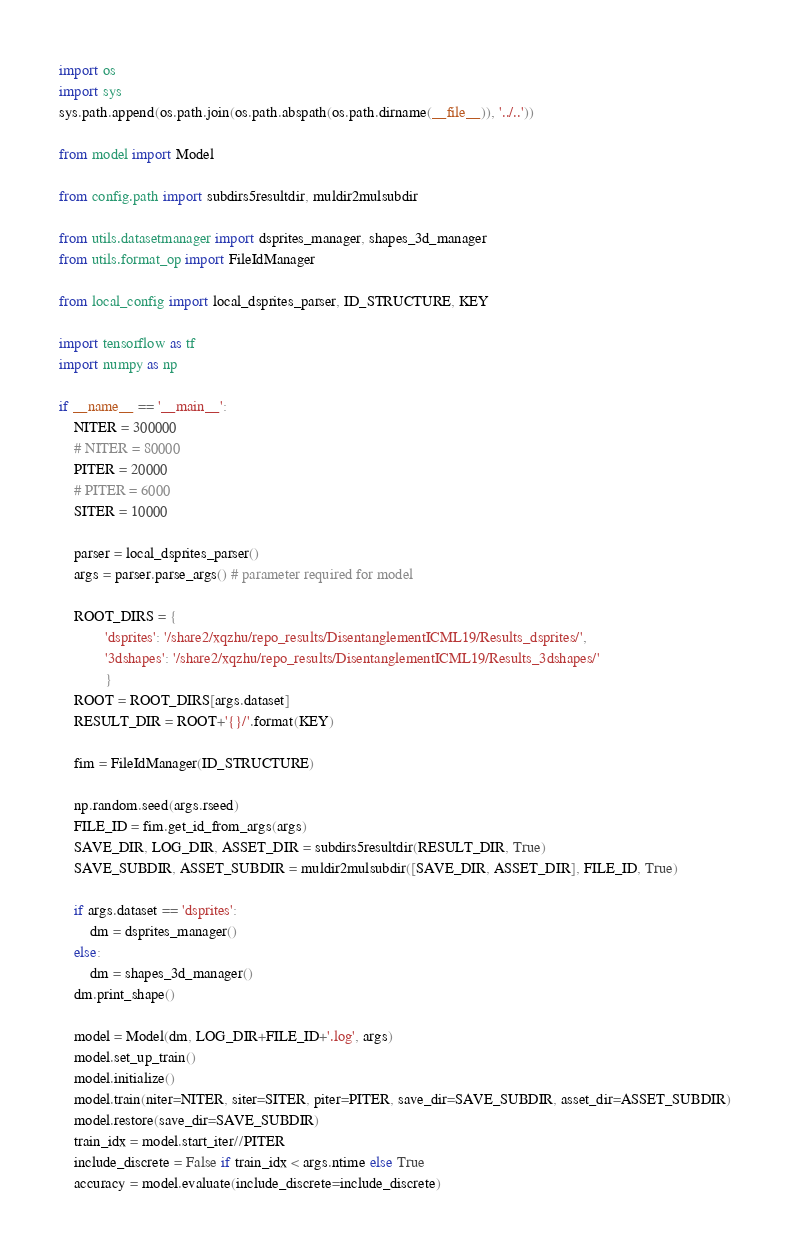Convert code to text. <code><loc_0><loc_0><loc_500><loc_500><_Python_>import os
import sys
sys.path.append(os.path.join(os.path.abspath(os.path.dirname(__file__)), '../..'))

from model import Model

from config.path import subdirs5resultdir, muldir2mulsubdir

from utils.datasetmanager import dsprites_manager, shapes_3d_manager
from utils.format_op import FileIdManager

from local_config import local_dsprites_parser, ID_STRUCTURE, KEY

import tensorflow as tf
import numpy as np

if __name__ == '__main__':
    NITER = 300000
    # NITER = 80000
    PITER = 20000
    # PITER = 6000
    SITER = 10000

    parser = local_dsprites_parser()
    args = parser.parse_args() # parameter required for model

    ROOT_DIRS = {
            'dsprites': '/share2/xqzhu/repo_results/DisentanglementICML19/Results_dsprites/',
            '3dshapes': '/share2/xqzhu/repo_results/DisentanglementICML19/Results_3dshapes/'
            }
    ROOT = ROOT_DIRS[args.dataset]
    RESULT_DIR = ROOT+'{}/'.format(KEY)

    fim = FileIdManager(ID_STRUCTURE)

    np.random.seed(args.rseed)
    FILE_ID = fim.get_id_from_args(args)
    SAVE_DIR, LOG_DIR, ASSET_DIR = subdirs5resultdir(RESULT_DIR, True)
    SAVE_SUBDIR, ASSET_SUBDIR = muldir2mulsubdir([SAVE_DIR, ASSET_DIR], FILE_ID, True)

    if args.dataset == 'dsprites':
        dm = dsprites_manager()
    else:
        dm = shapes_3d_manager()
    dm.print_shape()

    model = Model(dm, LOG_DIR+FILE_ID+'.log', args)
    model.set_up_train()
    model.initialize()
    model.train(niter=NITER, siter=SITER, piter=PITER, save_dir=SAVE_SUBDIR, asset_dir=ASSET_SUBDIR)
    model.restore(save_dir=SAVE_SUBDIR)
    train_idx = model.start_iter//PITER
    include_discrete = False if train_idx < args.ntime else True
    accuracy = model.evaluate(include_discrete=include_discrete)

</code> 